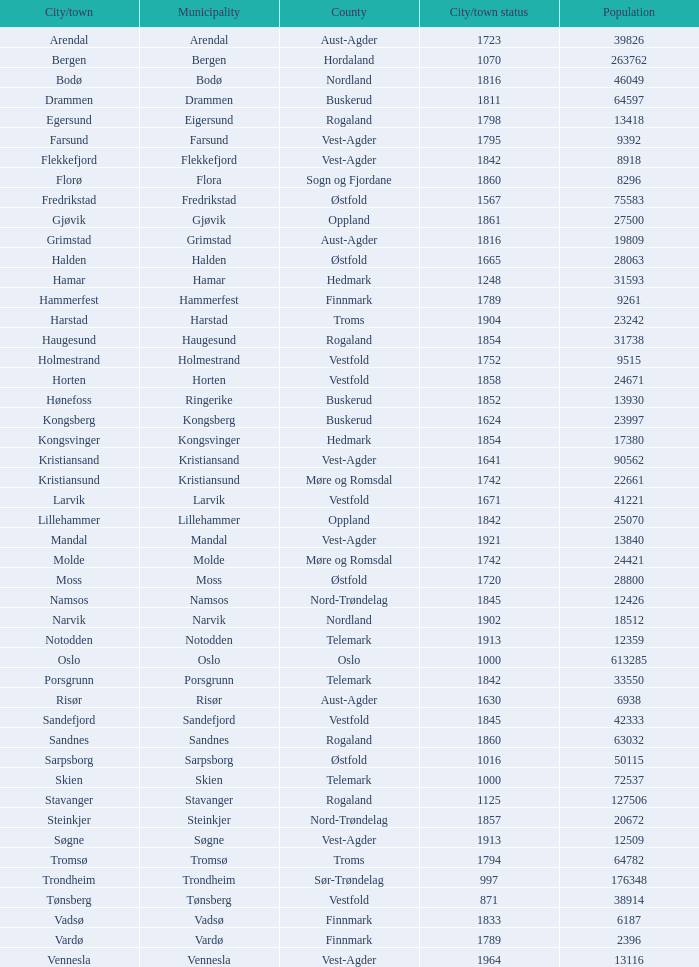How many people reside in the city/town of arendal? 1.0. 